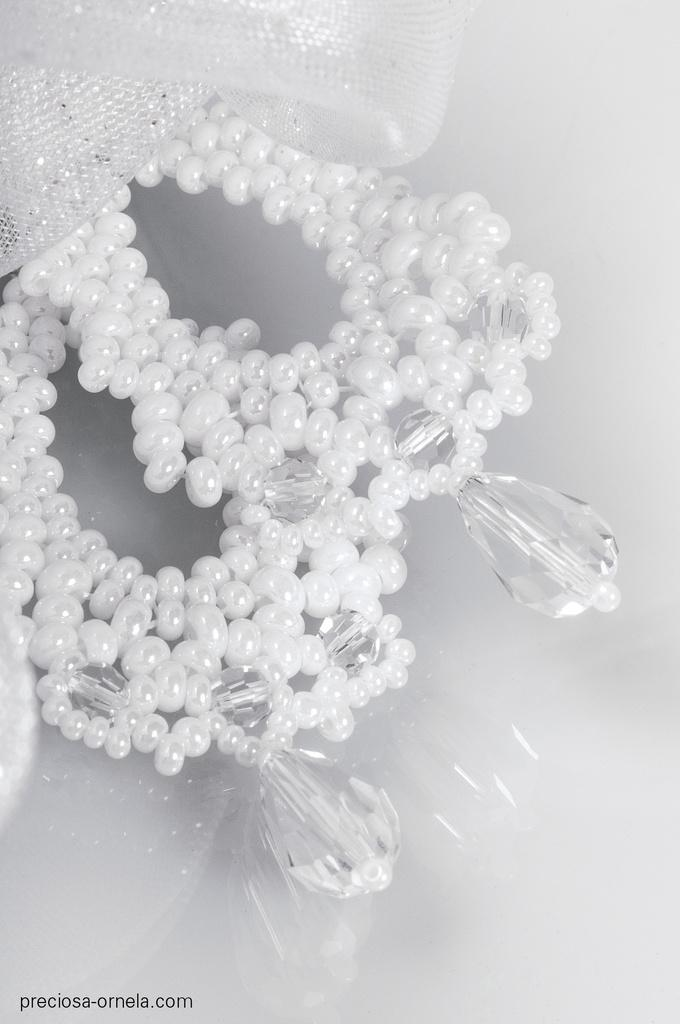What type of objects can be seen in the image? There are stones and beads in the image. Can you describe the stones in the image? The stones in the image are small and appear to be natural. What can be said about the beads in the image? The beads in the image are small and colorful. How many actors are present in the image? There are no actors present in the image; it features stones and beads. What type of creatures can be seen interacting with the beads in the image? There are no creatures present in the image; it features stones and beads only. 